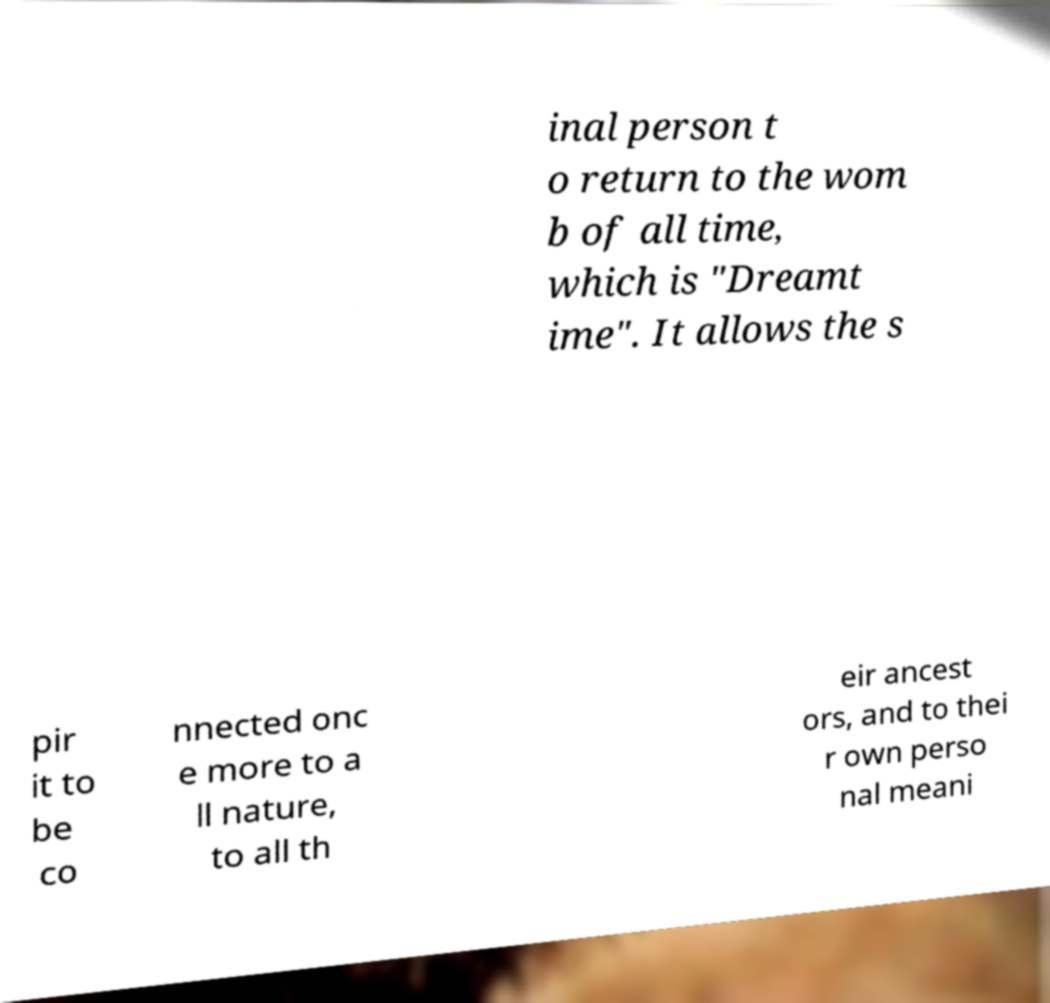I need the written content from this picture converted into text. Can you do that? inal person t o return to the wom b of all time, which is "Dreamt ime". It allows the s pir it to be co nnected onc e more to a ll nature, to all th eir ancest ors, and to thei r own perso nal meani 